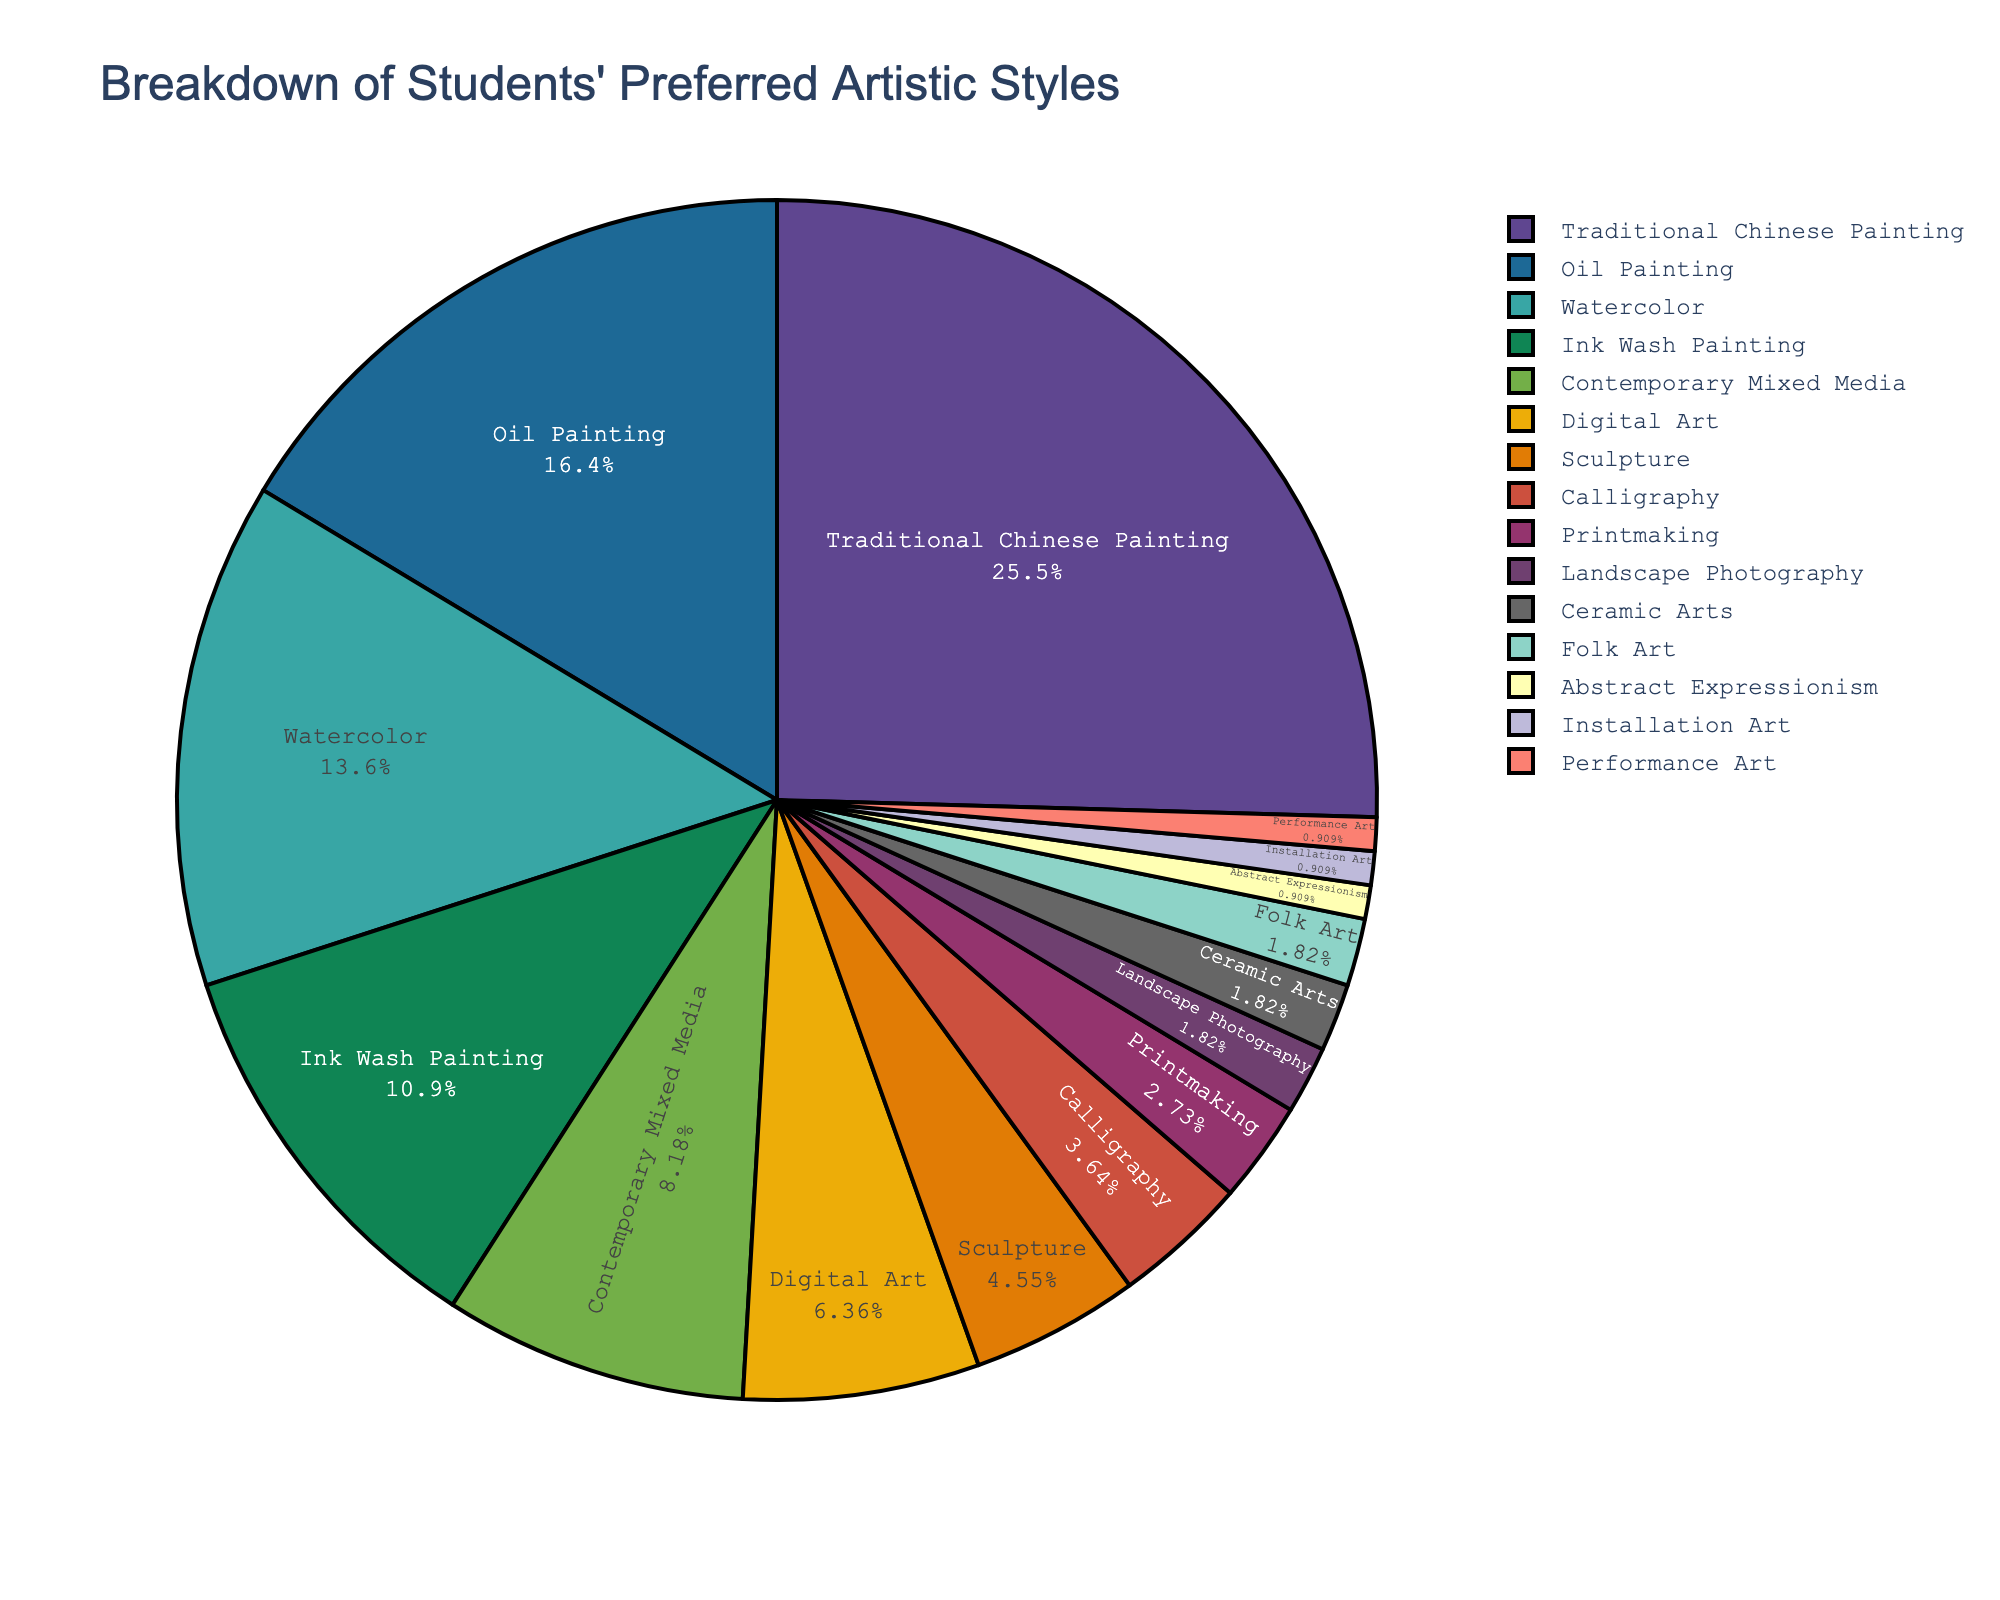What style do the majority of students prefer? The pie chart shows that the largest portion is labeled "Traditional Chinese Painting" with 28%, which is the highest percentage among all styles.
Answer: Traditional Chinese Painting How many styles have a percentage greater than 10%? From the chart, "Traditional Chinese Painting" (28%), "Oil Painting" (18%), "Watercolor" (15%), and "Ink Wash Painting" (12%) each have a percentage greater than 10%. Therefore, the number is four.
Answer: 4 Is Digital Art preferred more or less than Sculpture by students? The chart shows that Digital Art has a percentage of 7% while Sculpture has a percentage of 5%. Since 7% is greater than 5%, Digital Art is more preferred than Sculpture.
Answer: More What's the combined percentage of Calligraphy, Printmaking, and Landscape Photography? From the figure, Calligraphy has 4%, Printmaking has 3%, and Landscape Photography has 2%. Summing these percentages: 4% + 3% + 2% = 9%.
Answer: 9% Which two styles are equally preferred and have the smallest percentage? The pie chart shows that "Abstract Expressionism," "Installation Art," and "Performance Art" each have 1%. They are equally preferred and have the smallest percentage.
Answer: Abstract Expressionism, Installation Art, Performance Art Is the combined percentage of students preferring Contemporary Mixed Media and Digital Art greater than that of Oil Painting? Contemporary Mixed Media is 9% and Digital Art is 7%. Their combined percentage is 9% + 7% = 16%, which indeed is more than Oil Painting’s 18%.
Answer: No What's the difference in preference between Ink Wash Painting and Calligraphy? Ink Wash Painting has 12% and Calligraphy has 4%. The difference between them is 12% - 4% = 8%.
Answer: 8% What's the sum of percentages of the three least preferred styles? The three least preferred styles are Abstract Expressionism, Installation Art, and Performance Art, each with 1%. Summing these: 1% + 1% + 1% = 3%.
Answer: 3% What's the ratio of the percentage of students preferring Watercolor to those preferring Traditional Chinese Painting? Watercolor has 15% and Traditional Chinese Painting has 28%. The ratio is 15% / 28% = 0.536 approximately.
Answer: ~0.54 